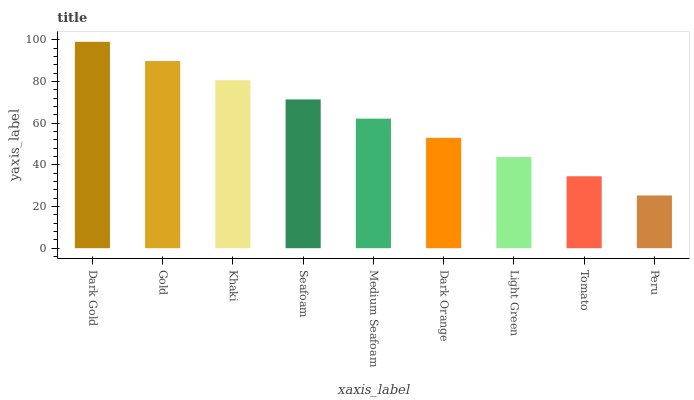Is Gold the minimum?
Answer yes or no. No. Is Gold the maximum?
Answer yes or no. No. Is Dark Gold greater than Gold?
Answer yes or no. Yes. Is Gold less than Dark Gold?
Answer yes or no. Yes. Is Gold greater than Dark Gold?
Answer yes or no. No. Is Dark Gold less than Gold?
Answer yes or no. No. Is Medium Seafoam the high median?
Answer yes or no. Yes. Is Medium Seafoam the low median?
Answer yes or no. Yes. Is Light Green the high median?
Answer yes or no. No. Is Tomato the low median?
Answer yes or no. No. 